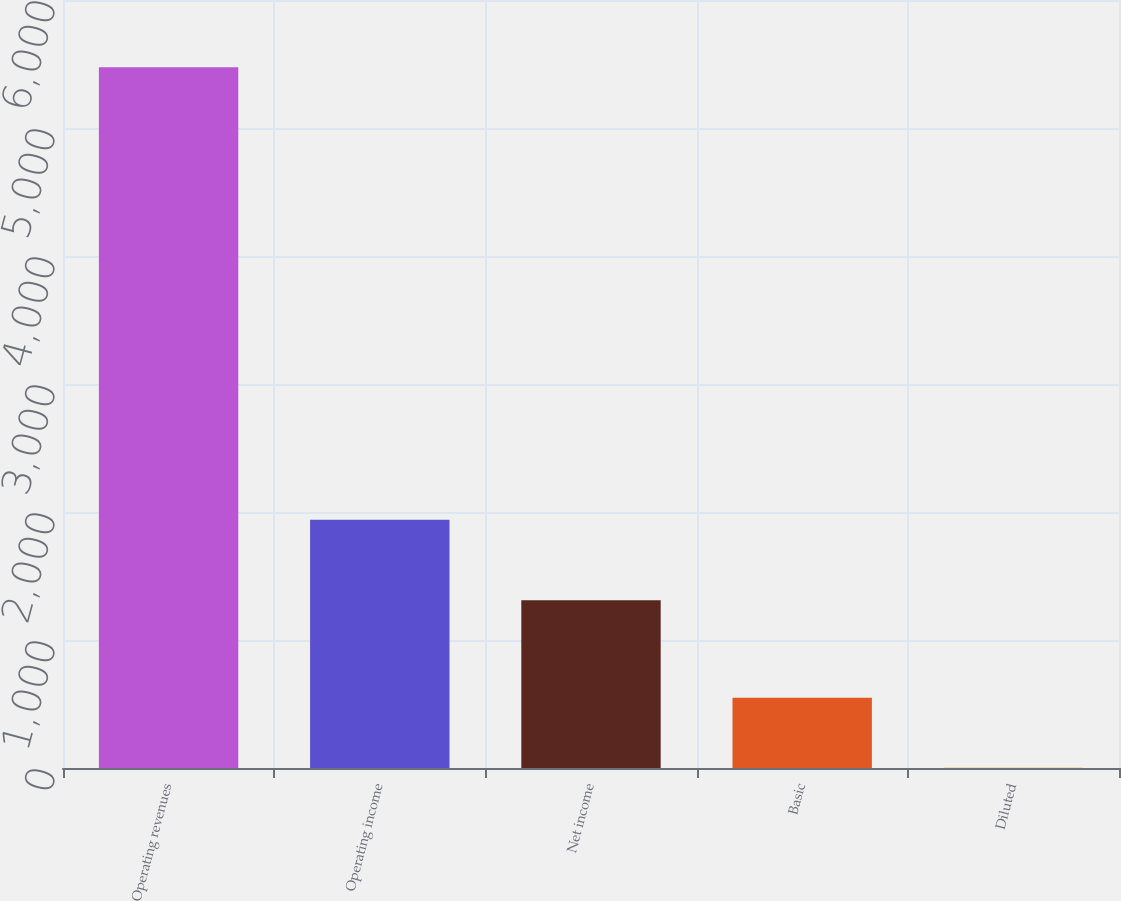<chart> <loc_0><loc_0><loc_500><loc_500><bar_chart><fcel>Operating revenues<fcel>Operating income<fcel>Net income<fcel>Basic<fcel>Diluted<nl><fcel>5475<fcel>1939<fcel>1310<fcel>549.01<fcel>1.68<nl></chart> 